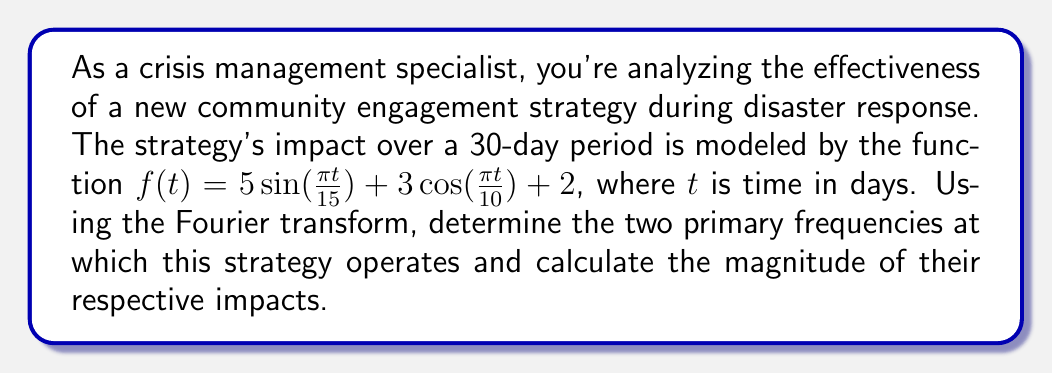Show me your answer to this math problem. To solve this problem, we'll follow these steps:

1) Identify the components of the given function:
   $f(t) = 5\sin(\frac{\pi t}{15}) + 3\cos(\frac{\pi t}{10}) + 2$

2) The Fourier transform deals with frequencies, so we need to convert our time-based function to frequency-based. The general form of a sinusoidal function is $A\sin(2\pi ft)$ or $A\cos(2\pi ft)$, where $f$ is the frequency.

3) For the sine term:
   $5\sin(\frac{\pi t}{15}) = 5\sin(2\pi \cdot \frac{1}{30}t)$
   So, $f_1 = \frac{1}{30}$ cycles per day

4) For the cosine term:
   $3\cos(\frac{\pi t}{10}) = 3\cos(2\pi \cdot \frac{1}{20}t)$
   So, $f_2 = \frac{1}{20}$ cycles per day

5) The constant term 2 corresponds to a frequency of 0.

6) The magnitude of impact for each frequency is given by the amplitude of each term:
   For $f_1 = \frac{1}{30}$, the magnitude is 5
   For $f_2 = \frac{1}{20}$, the magnitude is 3

Therefore, the two primary non-zero frequencies are $\frac{1}{30}$ and $\frac{1}{20}$ cycles per day, with magnitudes 5 and 3 respectively.
Answer: The two primary frequencies are $f_1 = \frac{1}{30}$ cycles/day and $f_2 = \frac{1}{20}$ cycles/day, with magnitudes of 5 and 3 respectively. 